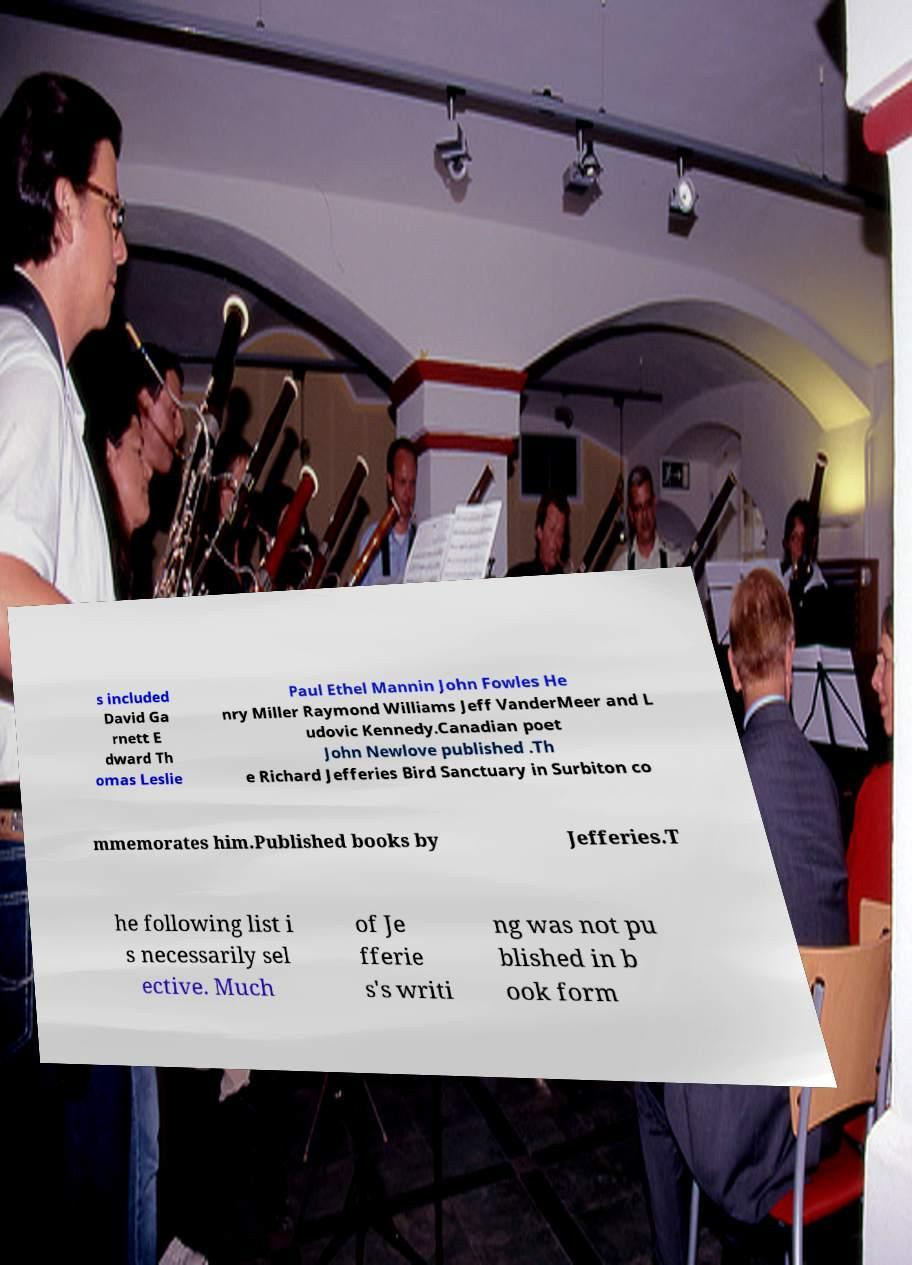Could you extract and type out the text from this image? s included David Ga rnett E dward Th omas Leslie Paul Ethel Mannin John Fowles He nry Miller Raymond Williams Jeff VanderMeer and L udovic Kennedy.Canadian poet John Newlove published .Th e Richard Jefferies Bird Sanctuary in Surbiton co mmemorates him.Published books by Jefferies.T he following list i s necessarily sel ective. Much of Je fferie s's writi ng was not pu blished in b ook form 